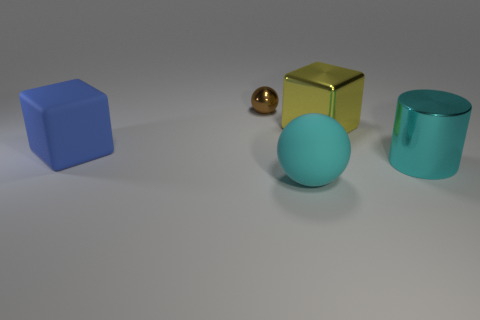What shape is the metal object that is in front of the small metal thing and behind the matte cube? The metal object positioned in front of the small, spherical metal item and behind the gold-colored cube has a spherical shape itself. 